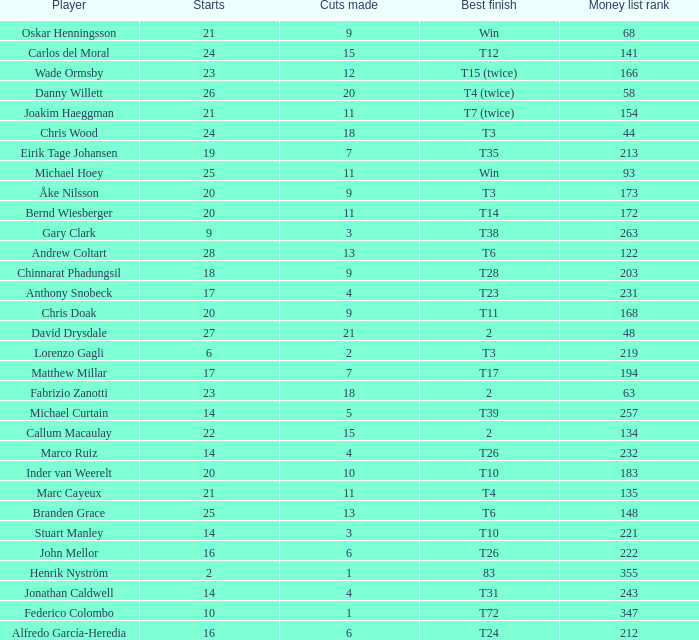How many cuts did Bernd Wiesberger make? 11.0. 